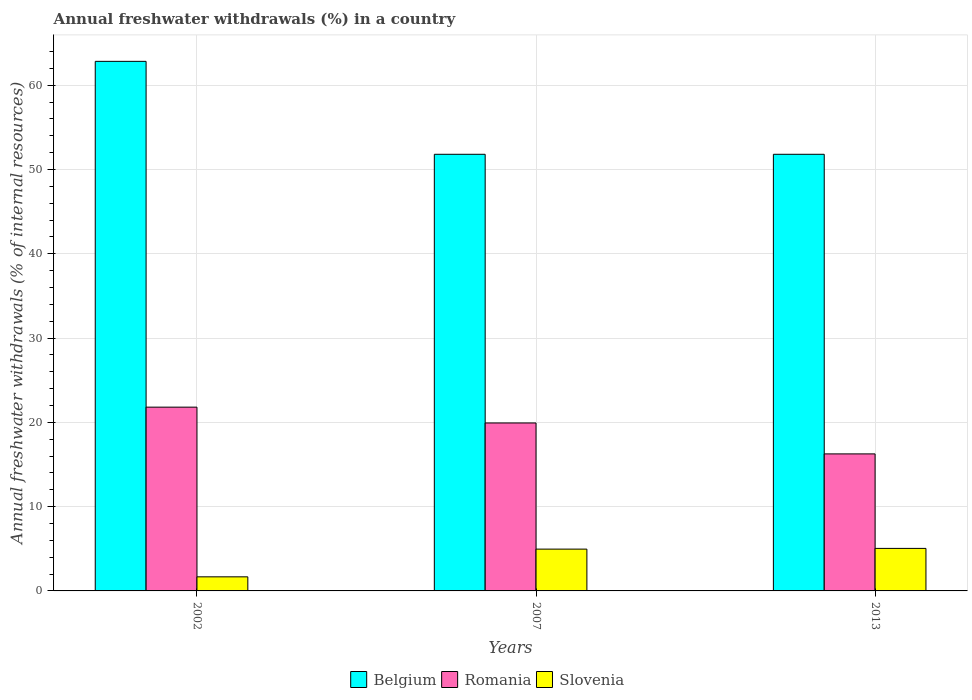How many different coloured bars are there?
Your answer should be compact. 3. Are the number of bars per tick equal to the number of legend labels?
Make the answer very short. Yes. What is the label of the 3rd group of bars from the left?
Your response must be concise. 2013. What is the percentage of annual freshwater withdrawals in Romania in 2013?
Provide a short and direct response. 16.26. Across all years, what is the maximum percentage of annual freshwater withdrawals in Slovenia?
Make the answer very short. 5.05. Across all years, what is the minimum percentage of annual freshwater withdrawals in Belgium?
Offer a terse response. 51.8. What is the total percentage of annual freshwater withdrawals in Belgium in the graph?
Your answer should be very brief. 166.43. What is the difference between the percentage of annual freshwater withdrawals in Slovenia in 2002 and that in 2007?
Keep it short and to the point. -3.29. What is the difference between the percentage of annual freshwater withdrawals in Slovenia in 2007 and the percentage of annual freshwater withdrawals in Romania in 2002?
Offer a very short reply. -16.84. What is the average percentage of annual freshwater withdrawals in Slovenia per year?
Make the answer very short. 3.89. In the year 2002, what is the difference between the percentage of annual freshwater withdrawals in Romania and percentage of annual freshwater withdrawals in Slovenia?
Provide a succinct answer. 20.13. What is the ratio of the percentage of annual freshwater withdrawals in Slovenia in 2002 to that in 2013?
Your answer should be compact. 0.33. Is the percentage of annual freshwater withdrawals in Belgium in 2002 less than that in 2007?
Your answer should be compact. No. What is the difference between the highest and the second highest percentage of annual freshwater withdrawals in Romania?
Offer a terse response. 1.87. What is the difference between the highest and the lowest percentage of annual freshwater withdrawals in Romania?
Give a very brief answer. 5.55. In how many years, is the percentage of annual freshwater withdrawals in Romania greater than the average percentage of annual freshwater withdrawals in Romania taken over all years?
Offer a terse response. 2. What does the 1st bar from the left in 2002 represents?
Provide a succinct answer. Belgium. What does the 2nd bar from the right in 2002 represents?
Make the answer very short. Romania. Is it the case that in every year, the sum of the percentage of annual freshwater withdrawals in Belgium and percentage of annual freshwater withdrawals in Slovenia is greater than the percentage of annual freshwater withdrawals in Romania?
Give a very brief answer. Yes. How many bars are there?
Provide a succinct answer. 9. Are all the bars in the graph horizontal?
Make the answer very short. No. What is the difference between two consecutive major ticks on the Y-axis?
Ensure brevity in your answer.  10. Does the graph contain grids?
Your answer should be very brief. Yes. How many legend labels are there?
Your answer should be compact. 3. What is the title of the graph?
Provide a succinct answer. Annual freshwater withdrawals (%) in a country. What is the label or title of the X-axis?
Your answer should be very brief. Years. What is the label or title of the Y-axis?
Offer a very short reply. Annual freshwater withdrawals (% of internal resources). What is the Annual freshwater withdrawals (% of internal resources) in Belgium in 2002?
Your answer should be compact. 62.83. What is the Annual freshwater withdrawals (% of internal resources) of Romania in 2002?
Your answer should be very brief. 21.8. What is the Annual freshwater withdrawals (% of internal resources) in Slovenia in 2002?
Provide a short and direct response. 1.67. What is the Annual freshwater withdrawals (% of internal resources) in Belgium in 2007?
Provide a succinct answer. 51.8. What is the Annual freshwater withdrawals (% of internal resources) of Romania in 2007?
Offer a terse response. 19.93. What is the Annual freshwater withdrawals (% of internal resources) in Slovenia in 2007?
Offer a terse response. 4.96. What is the Annual freshwater withdrawals (% of internal resources) in Belgium in 2013?
Keep it short and to the point. 51.8. What is the Annual freshwater withdrawals (% of internal resources) of Romania in 2013?
Ensure brevity in your answer.  16.26. What is the Annual freshwater withdrawals (% of internal resources) of Slovenia in 2013?
Offer a very short reply. 5.05. Across all years, what is the maximum Annual freshwater withdrawals (% of internal resources) of Belgium?
Provide a succinct answer. 62.83. Across all years, what is the maximum Annual freshwater withdrawals (% of internal resources) of Romania?
Provide a succinct answer. 21.8. Across all years, what is the maximum Annual freshwater withdrawals (% of internal resources) of Slovenia?
Provide a succinct answer. 5.05. Across all years, what is the minimum Annual freshwater withdrawals (% of internal resources) in Belgium?
Ensure brevity in your answer.  51.8. Across all years, what is the minimum Annual freshwater withdrawals (% of internal resources) in Romania?
Offer a terse response. 16.26. Across all years, what is the minimum Annual freshwater withdrawals (% of internal resources) in Slovenia?
Provide a short and direct response. 1.67. What is the total Annual freshwater withdrawals (% of internal resources) in Belgium in the graph?
Ensure brevity in your answer.  166.43. What is the total Annual freshwater withdrawals (% of internal resources) of Romania in the graph?
Provide a succinct answer. 57.98. What is the total Annual freshwater withdrawals (% of internal resources) of Slovenia in the graph?
Your answer should be compact. 11.68. What is the difference between the Annual freshwater withdrawals (% of internal resources) of Belgium in 2002 and that in 2007?
Make the answer very short. 11.03. What is the difference between the Annual freshwater withdrawals (% of internal resources) in Romania in 2002 and that in 2007?
Keep it short and to the point. 1.87. What is the difference between the Annual freshwater withdrawals (% of internal resources) in Slovenia in 2002 and that in 2007?
Give a very brief answer. -3.29. What is the difference between the Annual freshwater withdrawals (% of internal resources) of Belgium in 2002 and that in 2013?
Provide a succinct answer. 11.03. What is the difference between the Annual freshwater withdrawals (% of internal resources) in Romania in 2002 and that in 2013?
Ensure brevity in your answer.  5.55. What is the difference between the Annual freshwater withdrawals (% of internal resources) of Slovenia in 2002 and that in 2013?
Your answer should be compact. -3.37. What is the difference between the Annual freshwater withdrawals (% of internal resources) of Romania in 2007 and that in 2013?
Ensure brevity in your answer.  3.67. What is the difference between the Annual freshwater withdrawals (% of internal resources) in Slovenia in 2007 and that in 2013?
Offer a very short reply. -0.09. What is the difference between the Annual freshwater withdrawals (% of internal resources) in Belgium in 2002 and the Annual freshwater withdrawals (% of internal resources) in Romania in 2007?
Offer a very short reply. 42.9. What is the difference between the Annual freshwater withdrawals (% of internal resources) of Belgium in 2002 and the Annual freshwater withdrawals (% of internal resources) of Slovenia in 2007?
Your response must be concise. 57.87. What is the difference between the Annual freshwater withdrawals (% of internal resources) of Romania in 2002 and the Annual freshwater withdrawals (% of internal resources) of Slovenia in 2007?
Offer a very short reply. 16.84. What is the difference between the Annual freshwater withdrawals (% of internal resources) in Belgium in 2002 and the Annual freshwater withdrawals (% of internal resources) in Romania in 2013?
Offer a terse response. 46.57. What is the difference between the Annual freshwater withdrawals (% of internal resources) in Belgium in 2002 and the Annual freshwater withdrawals (% of internal resources) in Slovenia in 2013?
Ensure brevity in your answer.  57.78. What is the difference between the Annual freshwater withdrawals (% of internal resources) in Romania in 2002 and the Annual freshwater withdrawals (% of internal resources) in Slovenia in 2013?
Your answer should be compact. 16.76. What is the difference between the Annual freshwater withdrawals (% of internal resources) of Belgium in 2007 and the Annual freshwater withdrawals (% of internal resources) of Romania in 2013?
Make the answer very short. 35.54. What is the difference between the Annual freshwater withdrawals (% of internal resources) of Belgium in 2007 and the Annual freshwater withdrawals (% of internal resources) of Slovenia in 2013?
Your response must be concise. 46.75. What is the difference between the Annual freshwater withdrawals (% of internal resources) in Romania in 2007 and the Annual freshwater withdrawals (% of internal resources) in Slovenia in 2013?
Your response must be concise. 14.88. What is the average Annual freshwater withdrawals (% of internal resources) of Belgium per year?
Your answer should be compact. 55.48. What is the average Annual freshwater withdrawals (% of internal resources) in Romania per year?
Provide a short and direct response. 19.33. What is the average Annual freshwater withdrawals (% of internal resources) of Slovenia per year?
Offer a very short reply. 3.89. In the year 2002, what is the difference between the Annual freshwater withdrawals (% of internal resources) of Belgium and Annual freshwater withdrawals (% of internal resources) of Romania?
Give a very brief answer. 41.02. In the year 2002, what is the difference between the Annual freshwater withdrawals (% of internal resources) of Belgium and Annual freshwater withdrawals (% of internal resources) of Slovenia?
Ensure brevity in your answer.  61.15. In the year 2002, what is the difference between the Annual freshwater withdrawals (% of internal resources) in Romania and Annual freshwater withdrawals (% of internal resources) in Slovenia?
Your answer should be compact. 20.13. In the year 2007, what is the difference between the Annual freshwater withdrawals (% of internal resources) in Belgium and Annual freshwater withdrawals (% of internal resources) in Romania?
Your answer should be very brief. 31.87. In the year 2007, what is the difference between the Annual freshwater withdrawals (% of internal resources) in Belgium and Annual freshwater withdrawals (% of internal resources) in Slovenia?
Keep it short and to the point. 46.84. In the year 2007, what is the difference between the Annual freshwater withdrawals (% of internal resources) of Romania and Annual freshwater withdrawals (% of internal resources) of Slovenia?
Keep it short and to the point. 14.97. In the year 2013, what is the difference between the Annual freshwater withdrawals (% of internal resources) in Belgium and Annual freshwater withdrawals (% of internal resources) in Romania?
Give a very brief answer. 35.54. In the year 2013, what is the difference between the Annual freshwater withdrawals (% of internal resources) in Belgium and Annual freshwater withdrawals (% of internal resources) in Slovenia?
Your answer should be very brief. 46.75. In the year 2013, what is the difference between the Annual freshwater withdrawals (% of internal resources) of Romania and Annual freshwater withdrawals (% of internal resources) of Slovenia?
Offer a very short reply. 11.21. What is the ratio of the Annual freshwater withdrawals (% of internal resources) of Belgium in 2002 to that in 2007?
Provide a succinct answer. 1.21. What is the ratio of the Annual freshwater withdrawals (% of internal resources) in Romania in 2002 to that in 2007?
Provide a short and direct response. 1.09. What is the ratio of the Annual freshwater withdrawals (% of internal resources) in Slovenia in 2002 to that in 2007?
Give a very brief answer. 0.34. What is the ratio of the Annual freshwater withdrawals (% of internal resources) of Belgium in 2002 to that in 2013?
Make the answer very short. 1.21. What is the ratio of the Annual freshwater withdrawals (% of internal resources) of Romania in 2002 to that in 2013?
Make the answer very short. 1.34. What is the ratio of the Annual freshwater withdrawals (% of internal resources) of Slovenia in 2002 to that in 2013?
Your answer should be compact. 0.33. What is the ratio of the Annual freshwater withdrawals (% of internal resources) of Belgium in 2007 to that in 2013?
Give a very brief answer. 1. What is the ratio of the Annual freshwater withdrawals (% of internal resources) of Romania in 2007 to that in 2013?
Ensure brevity in your answer.  1.23. What is the difference between the highest and the second highest Annual freshwater withdrawals (% of internal resources) in Belgium?
Keep it short and to the point. 11.03. What is the difference between the highest and the second highest Annual freshwater withdrawals (% of internal resources) of Romania?
Ensure brevity in your answer.  1.87. What is the difference between the highest and the second highest Annual freshwater withdrawals (% of internal resources) in Slovenia?
Make the answer very short. 0.09. What is the difference between the highest and the lowest Annual freshwater withdrawals (% of internal resources) in Belgium?
Your answer should be compact. 11.03. What is the difference between the highest and the lowest Annual freshwater withdrawals (% of internal resources) in Romania?
Offer a very short reply. 5.55. What is the difference between the highest and the lowest Annual freshwater withdrawals (% of internal resources) of Slovenia?
Make the answer very short. 3.37. 